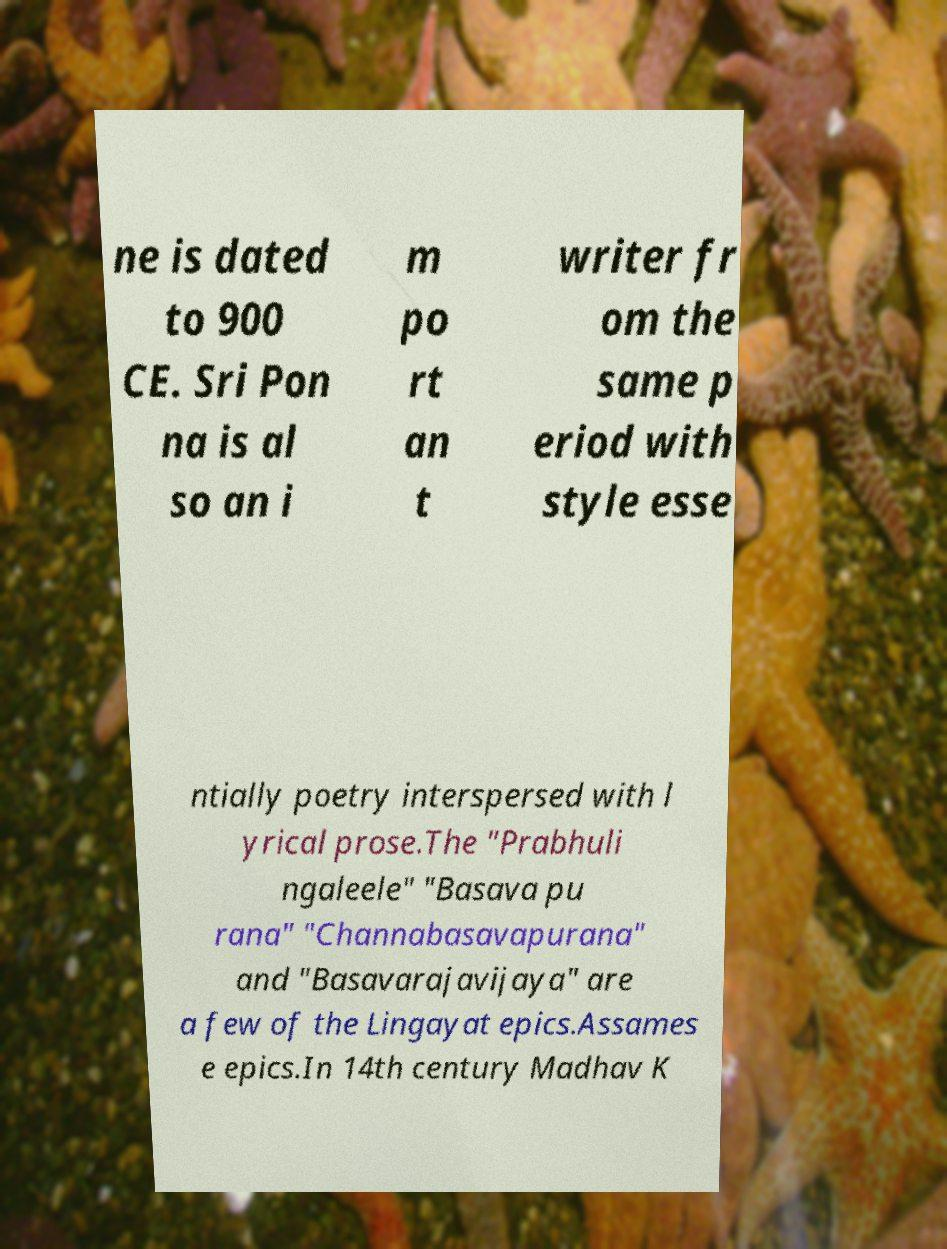What messages or text are displayed in this image? I need them in a readable, typed format. ne is dated to 900 CE. Sri Pon na is al so an i m po rt an t writer fr om the same p eriod with style esse ntially poetry interspersed with l yrical prose.The "Prabhuli ngaleele" "Basava pu rana" "Channabasavapurana" and "Basavarajavijaya" are a few of the Lingayat epics.Assames e epics.In 14th century Madhav K 